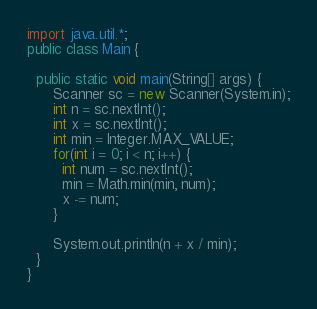<code> <loc_0><loc_0><loc_500><loc_500><_Java_>import java.util.*;
public class Main {

  public static void main(String[] args) { 
      Scanner sc = new Scanner(System.in);
      int n = sc.nextInt();
      int x = sc.nextInt();
      int min = Integer.MAX_VALUE;
      for(int i = 0; i < n; i++) {
        int num = sc.nextInt();
        min = Math.min(min, num);
        x -= num;
      }
      
      System.out.println(n + x / min);
  }
}</code> 